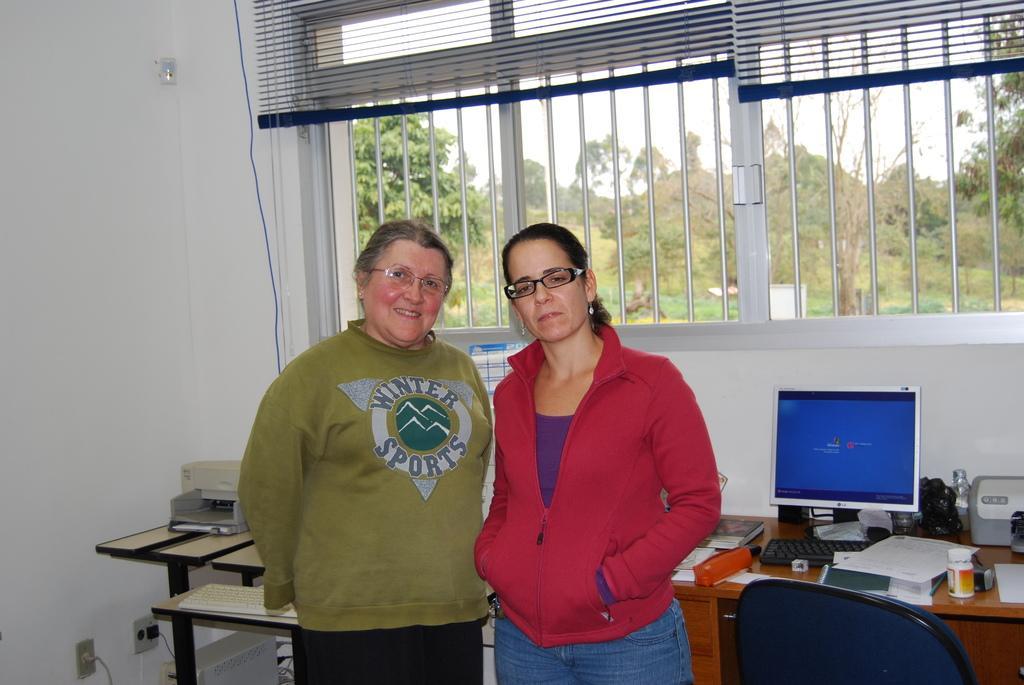Could you give a brief overview of what you see in this image? This picture is taken inside the room. In this image, in the middle, we can see two men are standing. In the right corner, we can see a chair. On the right side, we can see a table, on the table, we can see keyboard, monitor and few books, printer and a bottle. On the left side, we can also see another table. On the table, we can also see a keyboard and few objects. In the background, we can see a grill window, curtains, electric wires. At the bottom, we can also see a switch board. In the background, we can see a window, outside of the window, we can see some trees. At the top, we can see a sky. 